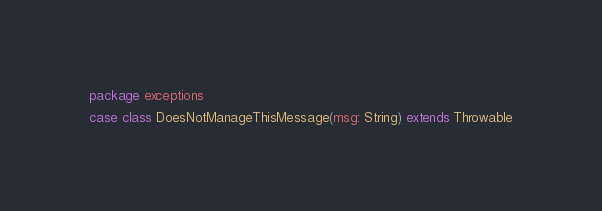Convert code to text. <code><loc_0><loc_0><loc_500><loc_500><_Scala_>package exceptions

case class DoesNotManageThisMessage(msg: String) extends Throwable
</code> 